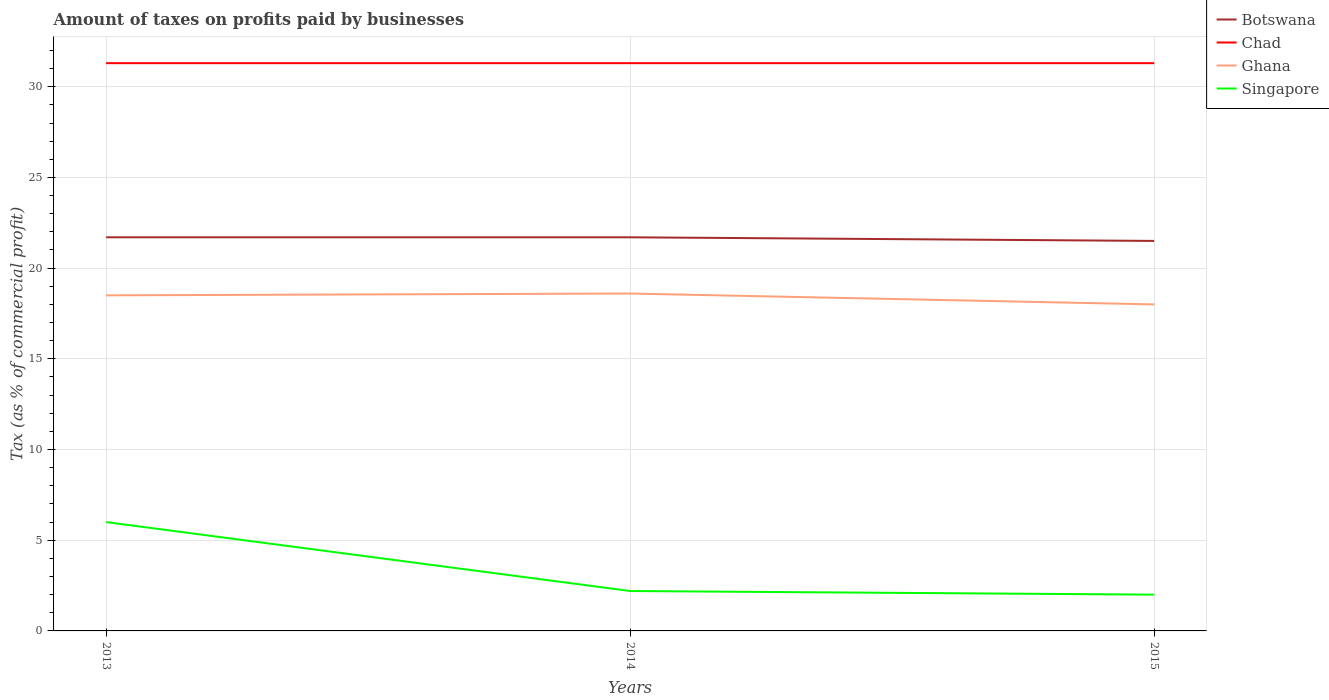Does the line corresponding to Botswana intersect with the line corresponding to Singapore?
Provide a succinct answer. No. Is the number of lines equal to the number of legend labels?
Offer a terse response. Yes. Across all years, what is the maximum percentage of taxes paid by businesses in Chad?
Provide a succinct answer. 31.3. In which year was the percentage of taxes paid by businesses in Singapore maximum?
Provide a short and direct response. 2015. What is the total percentage of taxes paid by businesses in Ghana in the graph?
Offer a terse response. 0.5. What is the difference between the highest and the second highest percentage of taxes paid by businesses in Ghana?
Offer a terse response. 0.6. What is the difference between the highest and the lowest percentage of taxes paid by businesses in Singapore?
Provide a short and direct response. 1. What is the difference between two consecutive major ticks on the Y-axis?
Ensure brevity in your answer.  5. How many legend labels are there?
Offer a terse response. 4. What is the title of the graph?
Offer a very short reply. Amount of taxes on profits paid by businesses. What is the label or title of the Y-axis?
Give a very brief answer. Tax (as % of commercial profit). What is the Tax (as % of commercial profit) of Botswana in 2013?
Give a very brief answer. 21.7. What is the Tax (as % of commercial profit) in Chad in 2013?
Ensure brevity in your answer.  31.3. What is the Tax (as % of commercial profit) of Ghana in 2013?
Your answer should be very brief. 18.5. What is the Tax (as % of commercial profit) in Botswana in 2014?
Offer a very short reply. 21.7. What is the Tax (as % of commercial profit) in Chad in 2014?
Give a very brief answer. 31.3. What is the Tax (as % of commercial profit) in Ghana in 2014?
Offer a terse response. 18.6. What is the Tax (as % of commercial profit) in Chad in 2015?
Give a very brief answer. 31.3. What is the Tax (as % of commercial profit) of Ghana in 2015?
Offer a terse response. 18. Across all years, what is the maximum Tax (as % of commercial profit) of Botswana?
Offer a very short reply. 21.7. Across all years, what is the maximum Tax (as % of commercial profit) in Chad?
Keep it short and to the point. 31.3. Across all years, what is the maximum Tax (as % of commercial profit) in Ghana?
Give a very brief answer. 18.6. Across all years, what is the minimum Tax (as % of commercial profit) of Chad?
Provide a succinct answer. 31.3. Across all years, what is the minimum Tax (as % of commercial profit) in Singapore?
Ensure brevity in your answer.  2. What is the total Tax (as % of commercial profit) in Botswana in the graph?
Provide a succinct answer. 64.9. What is the total Tax (as % of commercial profit) of Chad in the graph?
Offer a terse response. 93.9. What is the total Tax (as % of commercial profit) in Ghana in the graph?
Ensure brevity in your answer.  55.1. What is the difference between the Tax (as % of commercial profit) in Botswana in 2013 and that in 2014?
Your answer should be compact. 0. What is the difference between the Tax (as % of commercial profit) of Chad in 2013 and that in 2014?
Offer a terse response. 0. What is the difference between the Tax (as % of commercial profit) of Botswana in 2013 and that in 2015?
Give a very brief answer. 0.2. What is the difference between the Tax (as % of commercial profit) of Chad in 2013 and that in 2015?
Ensure brevity in your answer.  0. What is the difference between the Tax (as % of commercial profit) in Chad in 2014 and that in 2015?
Offer a terse response. 0. What is the difference between the Tax (as % of commercial profit) in Ghana in 2014 and that in 2015?
Give a very brief answer. 0.6. What is the difference between the Tax (as % of commercial profit) in Botswana in 2013 and the Tax (as % of commercial profit) in Singapore in 2014?
Provide a short and direct response. 19.5. What is the difference between the Tax (as % of commercial profit) in Chad in 2013 and the Tax (as % of commercial profit) in Singapore in 2014?
Make the answer very short. 29.1. What is the difference between the Tax (as % of commercial profit) in Botswana in 2013 and the Tax (as % of commercial profit) in Chad in 2015?
Your answer should be compact. -9.6. What is the difference between the Tax (as % of commercial profit) in Botswana in 2013 and the Tax (as % of commercial profit) in Singapore in 2015?
Give a very brief answer. 19.7. What is the difference between the Tax (as % of commercial profit) in Chad in 2013 and the Tax (as % of commercial profit) in Ghana in 2015?
Your response must be concise. 13.3. What is the difference between the Tax (as % of commercial profit) in Chad in 2013 and the Tax (as % of commercial profit) in Singapore in 2015?
Your answer should be compact. 29.3. What is the difference between the Tax (as % of commercial profit) of Botswana in 2014 and the Tax (as % of commercial profit) of Ghana in 2015?
Provide a succinct answer. 3.7. What is the difference between the Tax (as % of commercial profit) of Botswana in 2014 and the Tax (as % of commercial profit) of Singapore in 2015?
Ensure brevity in your answer.  19.7. What is the difference between the Tax (as % of commercial profit) in Chad in 2014 and the Tax (as % of commercial profit) in Singapore in 2015?
Offer a very short reply. 29.3. What is the difference between the Tax (as % of commercial profit) in Ghana in 2014 and the Tax (as % of commercial profit) in Singapore in 2015?
Your response must be concise. 16.6. What is the average Tax (as % of commercial profit) of Botswana per year?
Make the answer very short. 21.63. What is the average Tax (as % of commercial profit) in Chad per year?
Ensure brevity in your answer.  31.3. What is the average Tax (as % of commercial profit) of Ghana per year?
Make the answer very short. 18.37. In the year 2013, what is the difference between the Tax (as % of commercial profit) of Botswana and Tax (as % of commercial profit) of Chad?
Give a very brief answer. -9.6. In the year 2013, what is the difference between the Tax (as % of commercial profit) in Botswana and Tax (as % of commercial profit) in Ghana?
Your answer should be very brief. 3.2. In the year 2013, what is the difference between the Tax (as % of commercial profit) of Chad and Tax (as % of commercial profit) of Singapore?
Your answer should be compact. 25.3. In the year 2014, what is the difference between the Tax (as % of commercial profit) in Botswana and Tax (as % of commercial profit) in Ghana?
Your answer should be very brief. 3.1. In the year 2014, what is the difference between the Tax (as % of commercial profit) of Chad and Tax (as % of commercial profit) of Ghana?
Keep it short and to the point. 12.7. In the year 2014, what is the difference between the Tax (as % of commercial profit) of Chad and Tax (as % of commercial profit) of Singapore?
Offer a very short reply. 29.1. In the year 2014, what is the difference between the Tax (as % of commercial profit) of Ghana and Tax (as % of commercial profit) of Singapore?
Provide a short and direct response. 16.4. In the year 2015, what is the difference between the Tax (as % of commercial profit) of Botswana and Tax (as % of commercial profit) of Chad?
Offer a terse response. -9.8. In the year 2015, what is the difference between the Tax (as % of commercial profit) of Chad and Tax (as % of commercial profit) of Singapore?
Make the answer very short. 29.3. What is the ratio of the Tax (as % of commercial profit) of Botswana in 2013 to that in 2014?
Provide a short and direct response. 1. What is the ratio of the Tax (as % of commercial profit) in Chad in 2013 to that in 2014?
Give a very brief answer. 1. What is the ratio of the Tax (as % of commercial profit) of Ghana in 2013 to that in 2014?
Provide a succinct answer. 0.99. What is the ratio of the Tax (as % of commercial profit) in Singapore in 2013 to that in 2014?
Provide a short and direct response. 2.73. What is the ratio of the Tax (as % of commercial profit) of Botswana in 2013 to that in 2015?
Offer a terse response. 1.01. What is the ratio of the Tax (as % of commercial profit) of Chad in 2013 to that in 2015?
Offer a terse response. 1. What is the ratio of the Tax (as % of commercial profit) of Ghana in 2013 to that in 2015?
Your answer should be very brief. 1.03. What is the ratio of the Tax (as % of commercial profit) in Botswana in 2014 to that in 2015?
Offer a very short reply. 1.01. What is the ratio of the Tax (as % of commercial profit) of Chad in 2014 to that in 2015?
Your answer should be very brief. 1. What is the difference between the highest and the second highest Tax (as % of commercial profit) in Botswana?
Make the answer very short. 0. What is the difference between the highest and the second highest Tax (as % of commercial profit) of Chad?
Ensure brevity in your answer.  0. What is the difference between the highest and the second highest Tax (as % of commercial profit) in Singapore?
Your answer should be compact. 3.8. What is the difference between the highest and the lowest Tax (as % of commercial profit) of Chad?
Ensure brevity in your answer.  0. What is the difference between the highest and the lowest Tax (as % of commercial profit) of Singapore?
Your response must be concise. 4. 